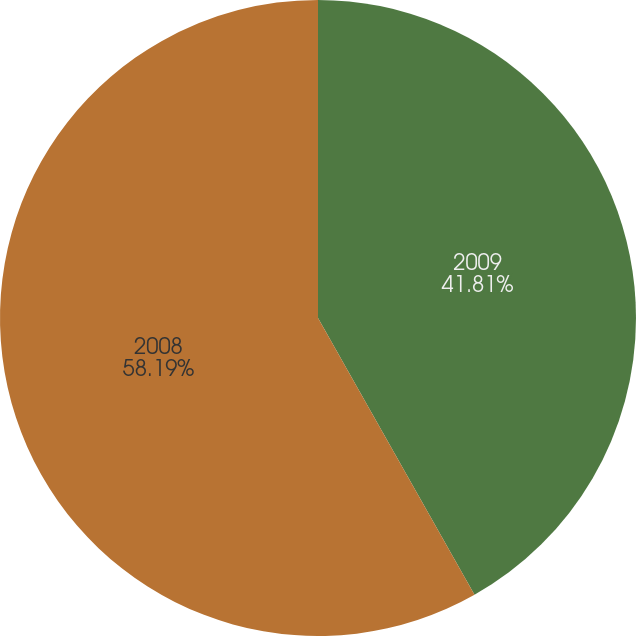<chart> <loc_0><loc_0><loc_500><loc_500><pie_chart><fcel>2009<fcel>2008<nl><fcel>41.81%<fcel>58.19%<nl></chart> 